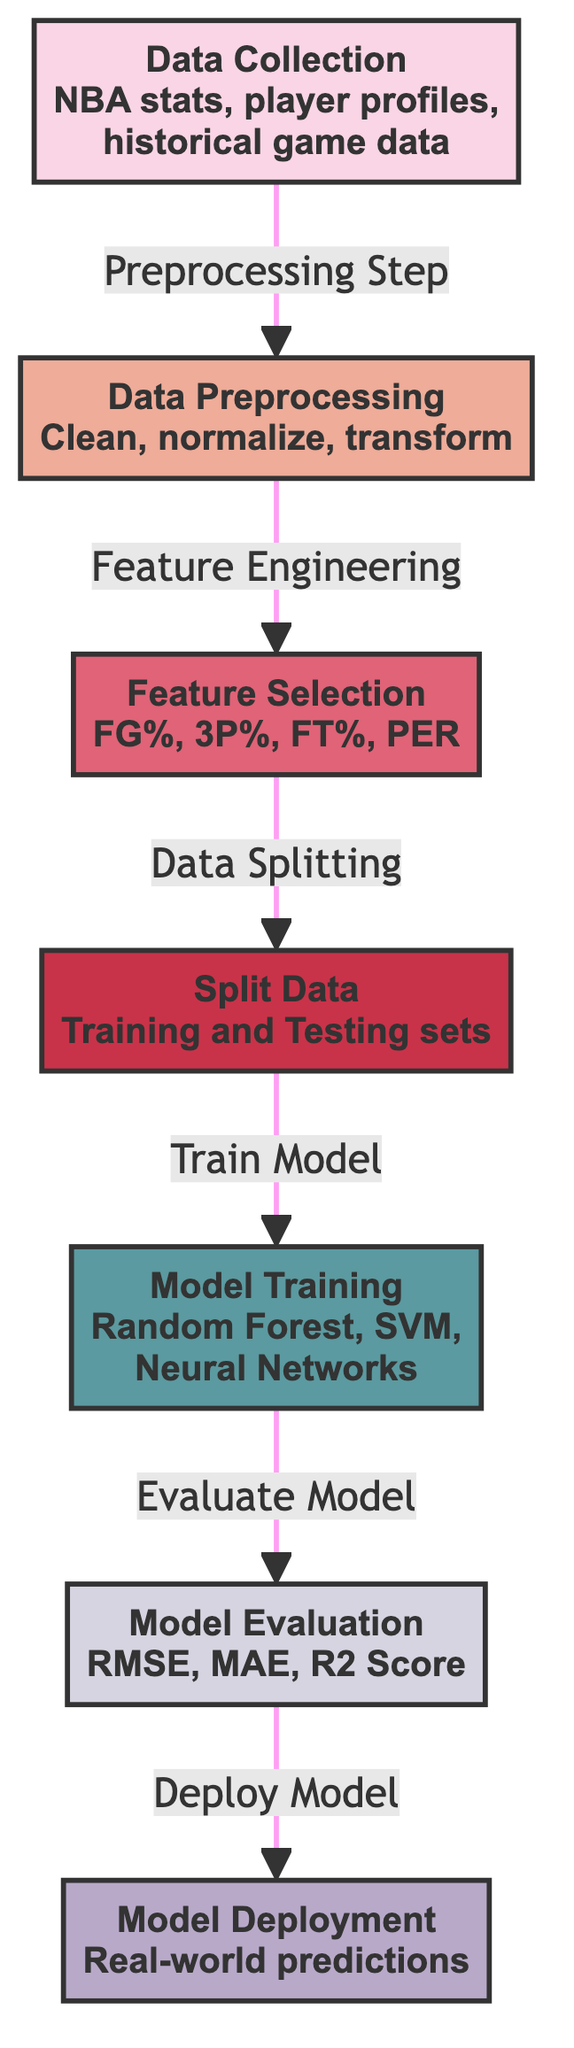What is the first step in the diagram? The first step in the diagram is "Data Collection", which involves gathering NBA stats, player profiles, and historical game data. This is indicated as the starting node in the flowchart.
Answer: Data Collection What type of model is used in the training step? The model training step mentions using multiple types of models: Random Forest, SVM, and Neural Networks. This indicates that various machine learning methods are considered for training.
Answer: Random Forest, SVM, Neural Networks How many evaluation metrics are included in the model evaluation step? The model evaluation step lists three metrics: RMSE, MAE, and R2 Score. Counting these gives a total of three evaluation metrics.
Answer: Three What follows the feature selection step in the flowchart? The step that follows "Feature Selection" in the flowchart is "Split Data". This indicates that after selecting features, the next action is to divide the dataset into training and testing sets.
Answer: Split Data What is the relationship between data preprocessing and feature selection? The relationship is defined as "Feature Engineering", meaning that after data preprocessing (cleaning and transforming data), feature selection is carried out to choose the relevant features for modeling.
Answer: Feature Engineering What is the purpose of the model deployment step? The purpose of the "Model Deployment" step is to make real-world predictions based on the trained model, indicating the practical application of all previous steps.
Answer: Real-world predictions Which preprocessing step is involved before feature selection? Before feature selection, the preprocessing step involved is "Data Preprocessing", which includes cleaning, normalizing, and transforming the collected data.
Answer: Data Preprocessing What happens after the model evaluation? After the model evaluation, the next step is "Model Deployment", which indicates that once the model is evaluated, it is deployed to make real-world predictions.
Answer: Model Deployment 